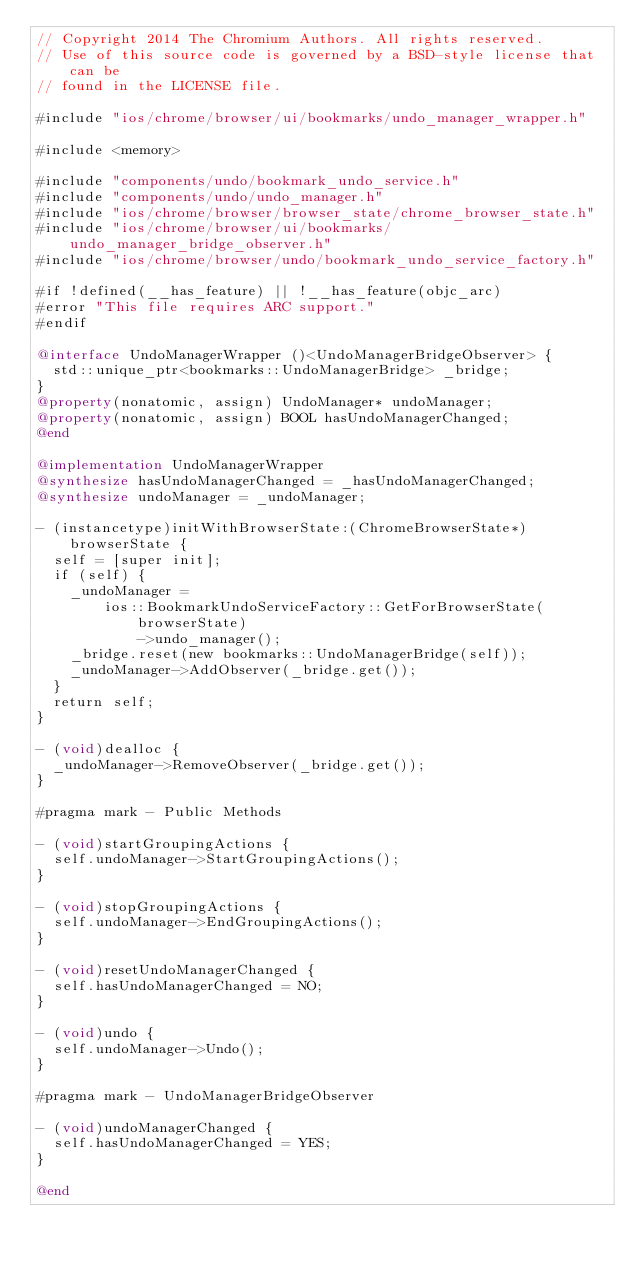Convert code to text. <code><loc_0><loc_0><loc_500><loc_500><_ObjectiveC_>// Copyright 2014 The Chromium Authors. All rights reserved.
// Use of this source code is governed by a BSD-style license that can be
// found in the LICENSE file.

#include "ios/chrome/browser/ui/bookmarks/undo_manager_wrapper.h"

#include <memory>

#include "components/undo/bookmark_undo_service.h"
#include "components/undo/undo_manager.h"
#include "ios/chrome/browser/browser_state/chrome_browser_state.h"
#include "ios/chrome/browser/ui/bookmarks/undo_manager_bridge_observer.h"
#include "ios/chrome/browser/undo/bookmark_undo_service_factory.h"

#if !defined(__has_feature) || !__has_feature(objc_arc)
#error "This file requires ARC support."
#endif

@interface UndoManagerWrapper ()<UndoManagerBridgeObserver> {
  std::unique_ptr<bookmarks::UndoManagerBridge> _bridge;
}
@property(nonatomic, assign) UndoManager* undoManager;
@property(nonatomic, assign) BOOL hasUndoManagerChanged;
@end

@implementation UndoManagerWrapper
@synthesize hasUndoManagerChanged = _hasUndoManagerChanged;
@synthesize undoManager = _undoManager;

- (instancetype)initWithBrowserState:(ChromeBrowserState*)browserState {
  self = [super init];
  if (self) {
    _undoManager =
        ios::BookmarkUndoServiceFactory::GetForBrowserState(browserState)
            ->undo_manager();
    _bridge.reset(new bookmarks::UndoManagerBridge(self));
    _undoManager->AddObserver(_bridge.get());
  }
  return self;
}

- (void)dealloc {
  _undoManager->RemoveObserver(_bridge.get());
}

#pragma mark - Public Methods

- (void)startGroupingActions {
  self.undoManager->StartGroupingActions();
}

- (void)stopGroupingActions {
  self.undoManager->EndGroupingActions();
}

- (void)resetUndoManagerChanged {
  self.hasUndoManagerChanged = NO;
}

- (void)undo {
  self.undoManager->Undo();
}

#pragma mark - UndoManagerBridgeObserver

- (void)undoManagerChanged {
  self.hasUndoManagerChanged = YES;
}

@end
</code> 